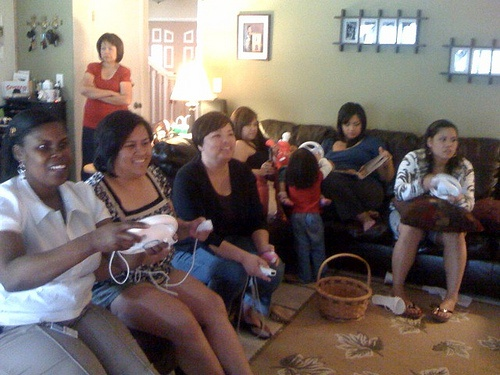Describe the objects in this image and their specific colors. I can see people in darkgray, gray, black, and lightblue tones, people in darkgray, brown, black, and maroon tones, people in darkgray, black, brown, and maroon tones, couch in darkgray, black, maroon, and gray tones, and people in darkgray, gray, black, and maroon tones in this image. 